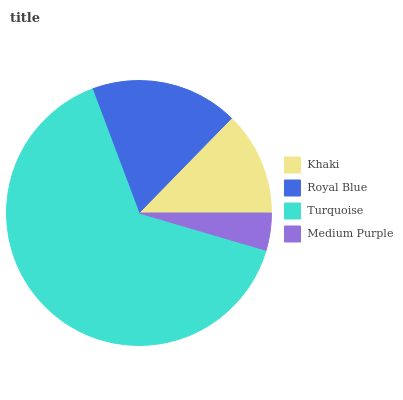Is Medium Purple the minimum?
Answer yes or no. Yes. Is Turquoise the maximum?
Answer yes or no. Yes. Is Royal Blue the minimum?
Answer yes or no. No. Is Royal Blue the maximum?
Answer yes or no. No. Is Royal Blue greater than Khaki?
Answer yes or no. Yes. Is Khaki less than Royal Blue?
Answer yes or no. Yes. Is Khaki greater than Royal Blue?
Answer yes or no. No. Is Royal Blue less than Khaki?
Answer yes or no. No. Is Royal Blue the high median?
Answer yes or no. Yes. Is Khaki the low median?
Answer yes or no. Yes. Is Turquoise the high median?
Answer yes or no. No. Is Turquoise the low median?
Answer yes or no. No. 